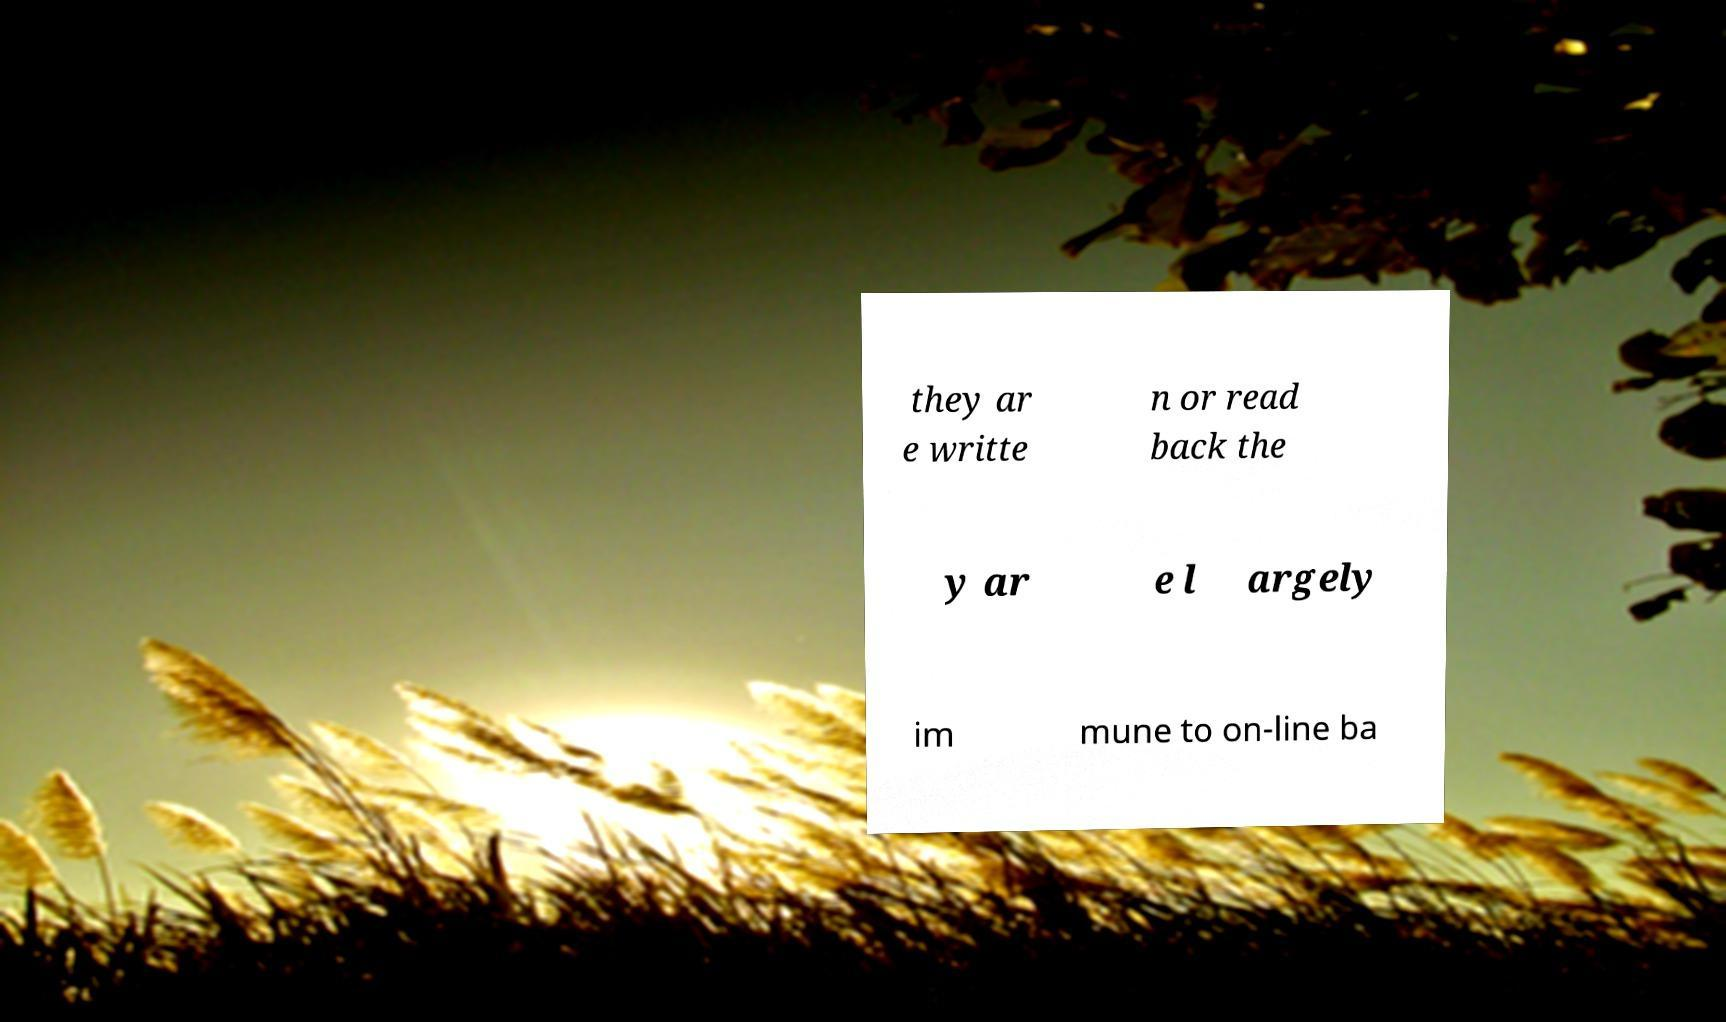Please identify and transcribe the text found in this image. they ar e writte n or read back the y ar e l argely im mune to on-line ba 